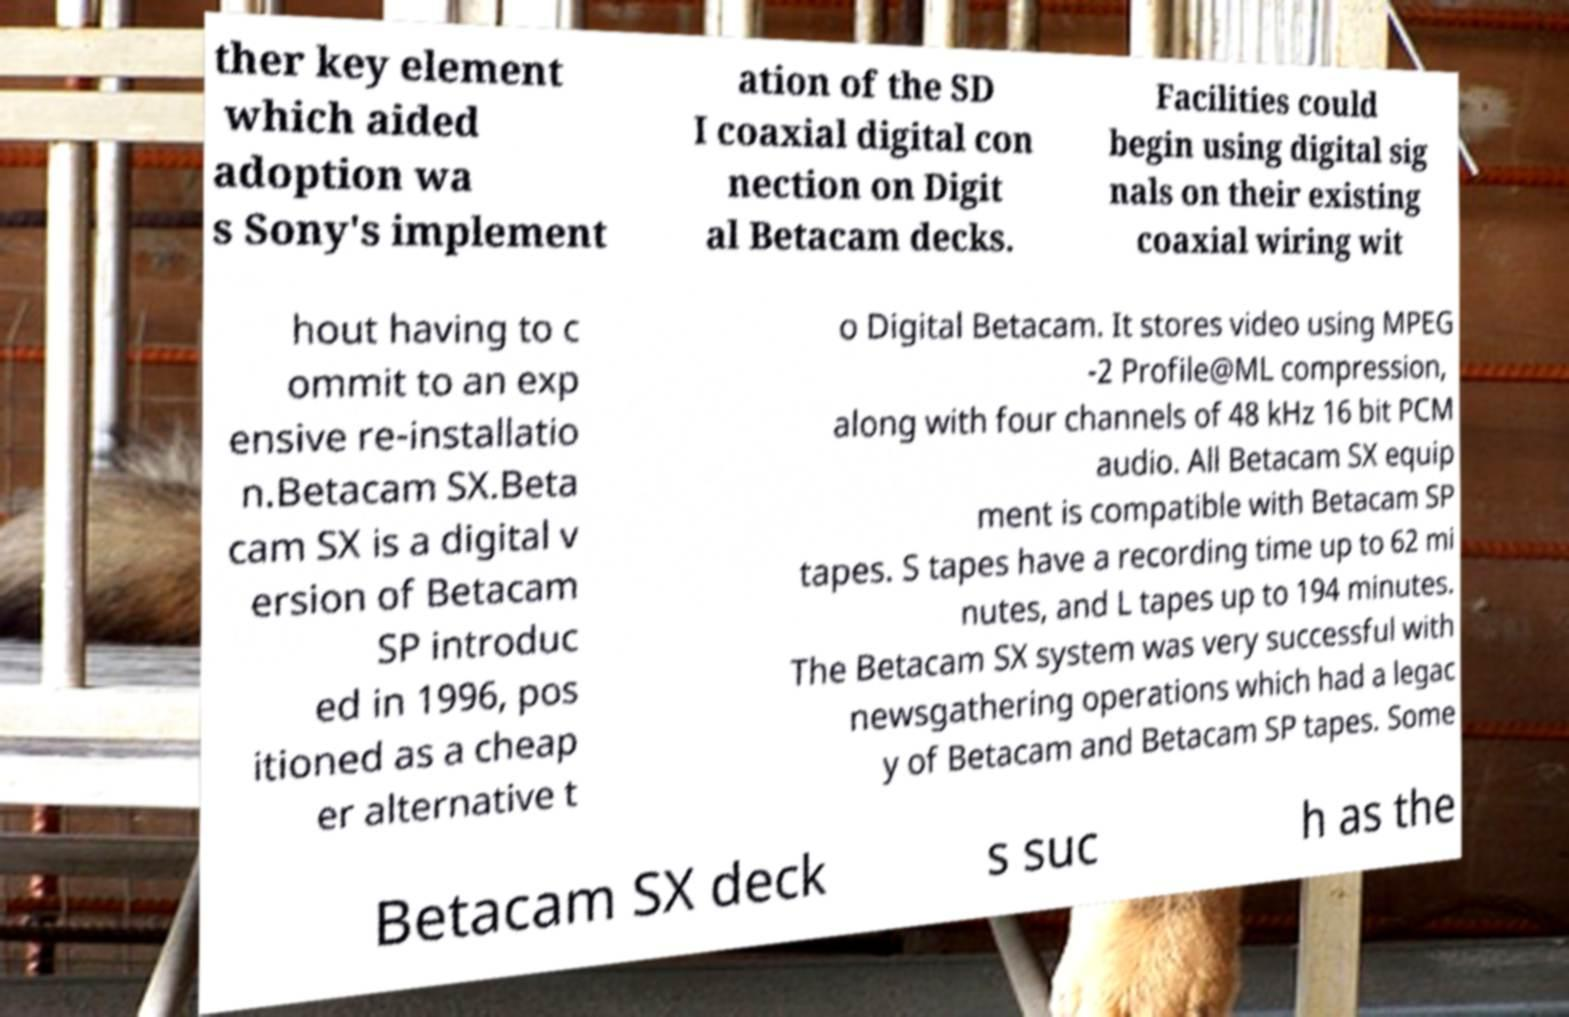Please identify and transcribe the text found in this image. ther key element which aided adoption wa s Sony's implement ation of the SD I coaxial digital con nection on Digit al Betacam decks. Facilities could begin using digital sig nals on their existing coaxial wiring wit hout having to c ommit to an exp ensive re-installatio n.Betacam SX.Beta cam SX is a digital v ersion of Betacam SP introduc ed in 1996, pos itioned as a cheap er alternative t o Digital Betacam. It stores video using MPEG -2 Profile@ML compression, along with four channels of 48 kHz 16 bit PCM audio. All Betacam SX equip ment is compatible with Betacam SP tapes. S tapes have a recording time up to 62 mi nutes, and L tapes up to 194 minutes. The Betacam SX system was very successful with newsgathering operations which had a legac y of Betacam and Betacam SP tapes. Some Betacam SX deck s suc h as the 